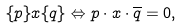Convert formula to latex. <formula><loc_0><loc_0><loc_500><loc_500>\{ p \} x \{ q \} \Leftrightarrow p \cdot x \cdot \overline { q } = 0 ,</formula> 